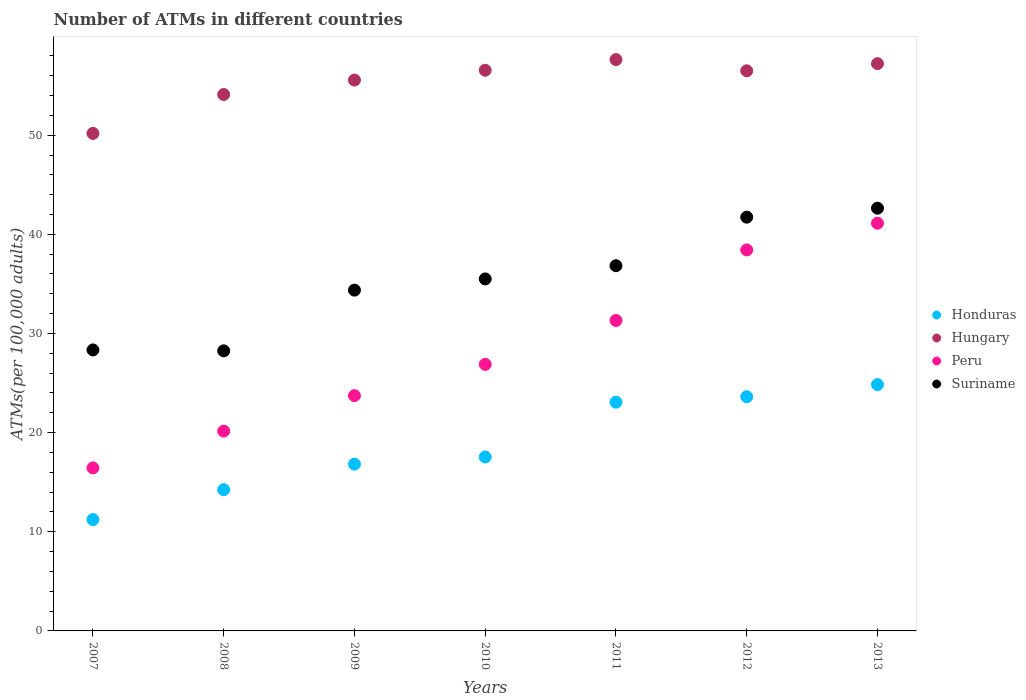What is the number of ATMs in Honduras in 2009?
Your response must be concise. 16.82. Across all years, what is the maximum number of ATMs in Suriname?
Keep it short and to the point. 42.64. Across all years, what is the minimum number of ATMs in Peru?
Give a very brief answer. 16.45. In which year was the number of ATMs in Hungary maximum?
Make the answer very short. 2011. In which year was the number of ATMs in Honduras minimum?
Offer a very short reply. 2007. What is the total number of ATMs in Honduras in the graph?
Offer a terse response. 131.38. What is the difference between the number of ATMs in Suriname in 2010 and that in 2013?
Give a very brief answer. -7.13. What is the difference between the number of ATMs in Honduras in 2013 and the number of ATMs in Suriname in 2008?
Offer a very short reply. -3.4. What is the average number of ATMs in Suriname per year?
Your answer should be very brief. 35.38. In the year 2012, what is the difference between the number of ATMs in Peru and number of ATMs in Honduras?
Ensure brevity in your answer.  14.81. In how many years, is the number of ATMs in Peru greater than 52?
Provide a succinct answer. 0. What is the ratio of the number of ATMs in Honduras in 2011 to that in 2013?
Your answer should be very brief. 0.93. Is the number of ATMs in Honduras in 2010 less than that in 2013?
Offer a very short reply. Yes. Is the difference between the number of ATMs in Peru in 2011 and 2012 greater than the difference between the number of ATMs in Honduras in 2011 and 2012?
Your answer should be compact. No. What is the difference between the highest and the second highest number of ATMs in Suriname?
Offer a terse response. 0.9. What is the difference between the highest and the lowest number of ATMs in Hungary?
Make the answer very short. 7.45. Is the sum of the number of ATMs in Hungary in 2008 and 2010 greater than the maximum number of ATMs in Peru across all years?
Offer a terse response. Yes. Is it the case that in every year, the sum of the number of ATMs in Hungary and number of ATMs in Peru  is greater than the number of ATMs in Honduras?
Your answer should be compact. Yes. Does the number of ATMs in Suriname monotonically increase over the years?
Your response must be concise. No. Is the number of ATMs in Hungary strictly less than the number of ATMs in Honduras over the years?
Provide a short and direct response. No. What is the difference between two consecutive major ticks on the Y-axis?
Offer a terse response. 10. Does the graph contain grids?
Provide a short and direct response. No. How many legend labels are there?
Ensure brevity in your answer.  4. What is the title of the graph?
Provide a short and direct response. Number of ATMs in different countries. What is the label or title of the Y-axis?
Provide a short and direct response. ATMs(per 100,0 adults). What is the ATMs(per 100,000 adults) in Honduras in 2007?
Provide a short and direct response. 11.23. What is the ATMs(per 100,000 adults) in Hungary in 2007?
Give a very brief answer. 50.18. What is the ATMs(per 100,000 adults) in Peru in 2007?
Give a very brief answer. 16.45. What is the ATMs(per 100,000 adults) in Suriname in 2007?
Your answer should be very brief. 28.34. What is the ATMs(per 100,000 adults) in Honduras in 2008?
Keep it short and to the point. 14.25. What is the ATMs(per 100,000 adults) in Hungary in 2008?
Keep it short and to the point. 54.1. What is the ATMs(per 100,000 adults) in Peru in 2008?
Offer a very short reply. 20.15. What is the ATMs(per 100,000 adults) in Suriname in 2008?
Ensure brevity in your answer.  28.25. What is the ATMs(per 100,000 adults) of Honduras in 2009?
Keep it short and to the point. 16.82. What is the ATMs(per 100,000 adults) of Hungary in 2009?
Keep it short and to the point. 55.56. What is the ATMs(per 100,000 adults) in Peru in 2009?
Your answer should be compact. 23.73. What is the ATMs(per 100,000 adults) of Suriname in 2009?
Your response must be concise. 34.37. What is the ATMs(per 100,000 adults) of Honduras in 2010?
Your answer should be very brief. 17.54. What is the ATMs(per 100,000 adults) of Hungary in 2010?
Ensure brevity in your answer.  56.55. What is the ATMs(per 100,000 adults) in Peru in 2010?
Offer a very short reply. 26.88. What is the ATMs(per 100,000 adults) in Suriname in 2010?
Provide a short and direct response. 35.5. What is the ATMs(per 100,000 adults) in Honduras in 2011?
Your response must be concise. 23.07. What is the ATMs(per 100,000 adults) of Hungary in 2011?
Provide a short and direct response. 57.63. What is the ATMs(per 100,000 adults) in Peru in 2011?
Your answer should be compact. 31.31. What is the ATMs(per 100,000 adults) in Suriname in 2011?
Your answer should be very brief. 36.83. What is the ATMs(per 100,000 adults) of Honduras in 2012?
Offer a very short reply. 23.62. What is the ATMs(per 100,000 adults) in Hungary in 2012?
Your answer should be very brief. 56.49. What is the ATMs(per 100,000 adults) in Peru in 2012?
Make the answer very short. 38.43. What is the ATMs(per 100,000 adults) of Suriname in 2012?
Give a very brief answer. 41.73. What is the ATMs(per 100,000 adults) in Honduras in 2013?
Offer a very short reply. 24.85. What is the ATMs(per 100,000 adults) in Hungary in 2013?
Your response must be concise. 57.22. What is the ATMs(per 100,000 adults) in Peru in 2013?
Offer a terse response. 41.12. What is the ATMs(per 100,000 adults) of Suriname in 2013?
Your answer should be very brief. 42.64. Across all years, what is the maximum ATMs(per 100,000 adults) in Honduras?
Offer a terse response. 24.85. Across all years, what is the maximum ATMs(per 100,000 adults) in Hungary?
Your answer should be compact. 57.63. Across all years, what is the maximum ATMs(per 100,000 adults) in Peru?
Give a very brief answer. 41.12. Across all years, what is the maximum ATMs(per 100,000 adults) of Suriname?
Your response must be concise. 42.64. Across all years, what is the minimum ATMs(per 100,000 adults) in Honduras?
Provide a succinct answer. 11.23. Across all years, what is the minimum ATMs(per 100,000 adults) in Hungary?
Your response must be concise. 50.18. Across all years, what is the minimum ATMs(per 100,000 adults) in Peru?
Your answer should be compact. 16.45. Across all years, what is the minimum ATMs(per 100,000 adults) in Suriname?
Give a very brief answer. 28.25. What is the total ATMs(per 100,000 adults) of Honduras in the graph?
Your answer should be compact. 131.38. What is the total ATMs(per 100,000 adults) in Hungary in the graph?
Provide a succinct answer. 387.73. What is the total ATMs(per 100,000 adults) in Peru in the graph?
Your answer should be very brief. 198.08. What is the total ATMs(per 100,000 adults) of Suriname in the graph?
Make the answer very short. 247.67. What is the difference between the ATMs(per 100,000 adults) in Honduras in 2007 and that in 2008?
Offer a very short reply. -3.02. What is the difference between the ATMs(per 100,000 adults) in Hungary in 2007 and that in 2008?
Offer a very short reply. -3.92. What is the difference between the ATMs(per 100,000 adults) in Peru in 2007 and that in 2008?
Ensure brevity in your answer.  -3.71. What is the difference between the ATMs(per 100,000 adults) of Suriname in 2007 and that in 2008?
Offer a terse response. 0.09. What is the difference between the ATMs(per 100,000 adults) of Honduras in 2007 and that in 2009?
Your response must be concise. -5.59. What is the difference between the ATMs(per 100,000 adults) of Hungary in 2007 and that in 2009?
Provide a short and direct response. -5.38. What is the difference between the ATMs(per 100,000 adults) of Peru in 2007 and that in 2009?
Give a very brief answer. -7.29. What is the difference between the ATMs(per 100,000 adults) in Suriname in 2007 and that in 2009?
Offer a very short reply. -6.03. What is the difference between the ATMs(per 100,000 adults) of Honduras in 2007 and that in 2010?
Give a very brief answer. -6.31. What is the difference between the ATMs(per 100,000 adults) of Hungary in 2007 and that in 2010?
Keep it short and to the point. -6.37. What is the difference between the ATMs(per 100,000 adults) of Peru in 2007 and that in 2010?
Make the answer very short. -10.44. What is the difference between the ATMs(per 100,000 adults) in Suriname in 2007 and that in 2010?
Your response must be concise. -7.16. What is the difference between the ATMs(per 100,000 adults) in Honduras in 2007 and that in 2011?
Offer a terse response. -11.84. What is the difference between the ATMs(per 100,000 adults) of Hungary in 2007 and that in 2011?
Offer a very short reply. -7.45. What is the difference between the ATMs(per 100,000 adults) in Peru in 2007 and that in 2011?
Offer a very short reply. -14.87. What is the difference between the ATMs(per 100,000 adults) of Suriname in 2007 and that in 2011?
Give a very brief answer. -8.49. What is the difference between the ATMs(per 100,000 adults) of Honduras in 2007 and that in 2012?
Give a very brief answer. -12.39. What is the difference between the ATMs(per 100,000 adults) of Hungary in 2007 and that in 2012?
Offer a terse response. -6.31. What is the difference between the ATMs(per 100,000 adults) in Peru in 2007 and that in 2012?
Give a very brief answer. -21.99. What is the difference between the ATMs(per 100,000 adults) of Suriname in 2007 and that in 2012?
Your answer should be very brief. -13.39. What is the difference between the ATMs(per 100,000 adults) in Honduras in 2007 and that in 2013?
Provide a succinct answer. -13.61. What is the difference between the ATMs(per 100,000 adults) of Hungary in 2007 and that in 2013?
Make the answer very short. -7.04. What is the difference between the ATMs(per 100,000 adults) in Peru in 2007 and that in 2013?
Offer a very short reply. -24.68. What is the difference between the ATMs(per 100,000 adults) of Suriname in 2007 and that in 2013?
Keep it short and to the point. -14.29. What is the difference between the ATMs(per 100,000 adults) in Honduras in 2008 and that in 2009?
Ensure brevity in your answer.  -2.58. What is the difference between the ATMs(per 100,000 adults) of Hungary in 2008 and that in 2009?
Make the answer very short. -1.46. What is the difference between the ATMs(per 100,000 adults) of Peru in 2008 and that in 2009?
Keep it short and to the point. -3.58. What is the difference between the ATMs(per 100,000 adults) in Suriname in 2008 and that in 2009?
Your answer should be compact. -6.12. What is the difference between the ATMs(per 100,000 adults) in Honduras in 2008 and that in 2010?
Ensure brevity in your answer.  -3.29. What is the difference between the ATMs(per 100,000 adults) of Hungary in 2008 and that in 2010?
Provide a succinct answer. -2.45. What is the difference between the ATMs(per 100,000 adults) in Peru in 2008 and that in 2010?
Your response must be concise. -6.73. What is the difference between the ATMs(per 100,000 adults) in Suriname in 2008 and that in 2010?
Make the answer very short. -7.25. What is the difference between the ATMs(per 100,000 adults) in Honduras in 2008 and that in 2011?
Make the answer very short. -8.83. What is the difference between the ATMs(per 100,000 adults) of Hungary in 2008 and that in 2011?
Provide a succinct answer. -3.52. What is the difference between the ATMs(per 100,000 adults) of Peru in 2008 and that in 2011?
Offer a terse response. -11.16. What is the difference between the ATMs(per 100,000 adults) in Suriname in 2008 and that in 2011?
Provide a short and direct response. -8.59. What is the difference between the ATMs(per 100,000 adults) in Honduras in 2008 and that in 2012?
Your response must be concise. -9.37. What is the difference between the ATMs(per 100,000 adults) of Hungary in 2008 and that in 2012?
Keep it short and to the point. -2.39. What is the difference between the ATMs(per 100,000 adults) of Peru in 2008 and that in 2012?
Your answer should be compact. -18.28. What is the difference between the ATMs(per 100,000 adults) in Suriname in 2008 and that in 2012?
Keep it short and to the point. -13.48. What is the difference between the ATMs(per 100,000 adults) in Honduras in 2008 and that in 2013?
Provide a short and direct response. -10.6. What is the difference between the ATMs(per 100,000 adults) of Hungary in 2008 and that in 2013?
Offer a very short reply. -3.11. What is the difference between the ATMs(per 100,000 adults) in Peru in 2008 and that in 2013?
Give a very brief answer. -20.97. What is the difference between the ATMs(per 100,000 adults) of Suriname in 2008 and that in 2013?
Ensure brevity in your answer.  -14.39. What is the difference between the ATMs(per 100,000 adults) of Honduras in 2009 and that in 2010?
Your response must be concise. -0.72. What is the difference between the ATMs(per 100,000 adults) of Hungary in 2009 and that in 2010?
Keep it short and to the point. -0.99. What is the difference between the ATMs(per 100,000 adults) of Peru in 2009 and that in 2010?
Keep it short and to the point. -3.15. What is the difference between the ATMs(per 100,000 adults) in Suriname in 2009 and that in 2010?
Offer a very short reply. -1.13. What is the difference between the ATMs(per 100,000 adults) of Honduras in 2009 and that in 2011?
Your response must be concise. -6.25. What is the difference between the ATMs(per 100,000 adults) in Hungary in 2009 and that in 2011?
Offer a terse response. -2.07. What is the difference between the ATMs(per 100,000 adults) of Peru in 2009 and that in 2011?
Keep it short and to the point. -7.58. What is the difference between the ATMs(per 100,000 adults) in Suriname in 2009 and that in 2011?
Make the answer very short. -2.46. What is the difference between the ATMs(per 100,000 adults) in Honduras in 2009 and that in 2012?
Offer a very short reply. -6.8. What is the difference between the ATMs(per 100,000 adults) of Hungary in 2009 and that in 2012?
Give a very brief answer. -0.93. What is the difference between the ATMs(per 100,000 adults) of Peru in 2009 and that in 2012?
Your answer should be very brief. -14.7. What is the difference between the ATMs(per 100,000 adults) of Suriname in 2009 and that in 2012?
Give a very brief answer. -7.36. What is the difference between the ATMs(per 100,000 adults) in Honduras in 2009 and that in 2013?
Keep it short and to the point. -8.02. What is the difference between the ATMs(per 100,000 adults) in Hungary in 2009 and that in 2013?
Give a very brief answer. -1.66. What is the difference between the ATMs(per 100,000 adults) of Peru in 2009 and that in 2013?
Offer a very short reply. -17.39. What is the difference between the ATMs(per 100,000 adults) of Suriname in 2009 and that in 2013?
Your response must be concise. -8.26. What is the difference between the ATMs(per 100,000 adults) in Honduras in 2010 and that in 2011?
Provide a succinct answer. -5.53. What is the difference between the ATMs(per 100,000 adults) of Hungary in 2010 and that in 2011?
Your answer should be very brief. -1.08. What is the difference between the ATMs(per 100,000 adults) of Peru in 2010 and that in 2011?
Keep it short and to the point. -4.43. What is the difference between the ATMs(per 100,000 adults) in Suriname in 2010 and that in 2011?
Offer a very short reply. -1.33. What is the difference between the ATMs(per 100,000 adults) of Honduras in 2010 and that in 2012?
Give a very brief answer. -6.08. What is the difference between the ATMs(per 100,000 adults) in Hungary in 2010 and that in 2012?
Make the answer very short. 0.06. What is the difference between the ATMs(per 100,000 adults) of Peru in 2010 and that in 2012?
Make the answer very short. -11.55. What is the difference between the ATMs(per 100,000 adults) in Suriname in 2010 and that in 2012?
Make the answer very short. -6.23. What is the difference between the ATMs(per 100,000 adults) of Honduras in 2010 and that in 2013?
Offer a very short reply. -7.3. What is the difference between the ATMs(per 100,000 adults) of Hungary in 2010 and that in 2013?
Keep it short and to the point. -0.67. What is the difference between the ATMs(per 100,000 adults) of Peru in 2010 and that in 2013?
Your response must be concise. -14.24. What is the difference between the ATMs(per 100,000 adults) of Suriname in 2010 and that in 2013?
Your response must be concise. -7.13. What is the difference between the ATMs(per 100,000 adults) in Honduras in 2011 and that in 2012?
Make the answer very short. -0.55. What is the difference between the ATMs(per 100,000 adults) of Hungary in 2011 and that in 2012?
Offer a terse response. 1.13. What is the difference between the ATMs(per 100,000 adults) in Peru in 2011 and that in 2012?
Make the answer very short. -7.12. What is the difference between the ATMs(per 100,000 adults) in Suriname in 2011 and that in 2012?
Keep it short and to the point. -4.9. What is the difference between the ATMs(per 100,000 adults) of Honduras in 2011 and that in 2013?
Make the answer very short. -1.77. What is the difference between the ATMs(per 100,000 adults) in Hungary in 2011 and that in 2013?
Your response must be concise. 0.41. What is the difference between the ATMs(per 100,000 adults) in Peru in 2011 and that in 2013?
Keep it short and to the point. -9.81. What is the difference between the ATMs(per 100,000 adults) of Suriname in 2011 and that in 2013?
Provide a succinct answer. -5.8. What is the difference between the ATMs(per 100,000 adults) of Honduras in 2012 and that in 2013?
Give a very brief answer. -1.22. What is the difference between the ATMs(per 100,000 adults) in Hungary in 2012 and that in 2013?
Make the answer very short. -0.72. What is the difference between the ATMs(per 100,000 adults) in Peru in 2012 and that in 2013?
Offer a very short reply. -2.69. What is the difference between the ATMs(per 100,000 adults) of Suriname in 2012 and that in 2013?
Provide a succinct answer. -0.9. What is the difference between the ATMs(per 100,000 adults) of Honduras in 2007 and the ATMs(per 100,000 adults) of Hungary in 2008?
Offer a very short reply. -42.87. What is the difference between the ATMs(per 100,000 adults) of Honduras in 2007 and the ATMs(per 100,000 adults) of Peru in 2008?
Keep it short and to the point. -8.92. What is the difference between the ATMs(per 100,000 adults) of Honduras in 2007 and the ATMs(per 100,000 adults) of Suriname in 2008?
Provide a short and direct response. -17.02. What is the difference between the ATMs(per 100,000 adults) in Hungary in 2007 and the ATMs(per 100,000 adults) in Peru in 2008?
Keep it short and to the point. 30.03. What is the difference between the ATMs(per 100,000 adults) of Hungary in 2007 and the ATMs(per 100,000 adults) of Suriname in 2008?
Offer a terse response. 21.93. What is the difference between the ATMs(per 100,000 adults) in Peru in 2007 and the ATMs(per 100,000 adults) in Suriname in 2008?
Your answer should be compact. -11.8. What is the difference between the ATMs(per 100,000 adults) in Honduras in 2007 and the ATMs(per 100,000 adults) in Hungary in 2009?
Offer a very short reply. -44.33. What is the difference between the ATMs(per 100,000 adults) in Honduras in 2007 and the ATMs(per 100,000 adults) in Peru in 2009?
Your response must be concise. -12.5. What is the difference between the ATMs(per 100,000 adults) in Honduras in 2007 and the ATMs(per 100,000 adults) in Suriname in 2009?
Give a very brief answer. -23.14. What is the difference between the ATMs(per 100,000 adults) in Hungary in 2007 and the ATMs(per 100,000 adults) in Peru in 2009?
Your response must be concise. 26.45. What is the difference between the ATMs(per 100,000 adults) in Hungary in 2007 and the ATMs(per 100,000 adults) in Suriname in 2009?
Provide a succinct answer. 15.81. What is the difference between the ATMs(per 100,000 adults) of Peru in 2007 and the ATMs(per 100,000 adults) of Suriname in 2009?
Your answer should be very brief. -17.93. What is the difference between the ATMs(per 100,000 adults) in Honduras in 2007 and the ATMs(per 100,000 adults) in Hungary in 2010?
Ensure brevity in your answer.  -45.32. What is the difference between the ATMs(per 100,000 adults) in Honduras in 2007 and the ATMs(per 100,000 adults) in Peru in 2010?
Make the answer very short. -15.65. What is the difference between the ATMs(per 100,000 adults) of Honduras in 2007 and the ATMs(per 100,000 adults) of Suriname in 2010?
Provide a succinct answer. -24.27. What is the difference between the ATMs(per 100,000 adults) in Hungary in 2007 and the ATMs(per 100,000 adults) in Peru in 2010?
Provide a short and direct response. 23.3. What is the difference between the ATMs(per 100,000 adults) in Hungary in 2007 and the ATMs(per 100,000 adults) in Suriname in 2010?
Your answer should be compact. 14.68. What is the difference between the ATMs(per 100,000 adults) in Peru in 2007 and the ATMs(per 100,000 adults) in Suriname in 2010?
Keep it short and to the point. -19.06. What is the difference between the ATMs(per 100,000 adults) in Honduras in 2007 and the ATMs(per 100,000 adults) in Hungary in 2011?
Make the answer very short. -46.4. What is the difference between the ATMs(per 100,000 adults) of Honduras in 2007 and the ATMs(per 100,000 adults) of Peru in 2011?
Make the answer very short. -20.08. What is the difference between the ATMs(per 100,000 adults) of Honduras in 2007 and the ATMs(per 100,000 adults) of Suriname in 2011?
Your answer should be compact. -25.6. What is the difference between the ATMs(per 100,000 adults) in Hungary in 2007 and the ATMs(per 100,000 adults) in Peru in 2011?
Give a very brief answer. 18.87. What is the difference between the ATMs(per 100,000 adults) of Hungary in 2007 and the ATMs(per 100,000 adults) of Suriname in 2011?
Ensure brevity in your answer.  13.35. What is the difference between the ATMs(per 100,000 adults) in Peru in 2007 and the ATMs(per 100,000 adults) in Suriname in 2011?
Provide a short and direct response. -20.39. What is the difference between the ATMs(per 100,000 adults) of Honduras in 2007 and the ATMs(per 100,000 adults) of Hungary in 2012?
Provide a succinct answer. -45.26. What is the difference between the ATMs(per 100,000 adults) of Honduras in 2007 and the ATMs(per 100,000 adults) of Peru in 2012?
Your answer should be compact. -27.2. What is the difference between the ATMs(per 100,000 adults) of Honduras in 2007 and the ATMs(per 100,000 adults) of Suriname in 2012?
Provide a short and direct response. -30.5. What is the difference between the ATMs(per 100,000 adults) in Hungary in 2007 and the ATMs(per 100,000 adults) in Peru in 2012?
Ensure brevity in your answer.  11.75. What is the difference between the ATMs(per 100,000 adults) of Hungary in 2007 and the ATMs(per 100,000 adults) of Suriname in 2012?
Keep it short and to the point. 8.45. What is the difference between the ATMs(per 100,000 adults) of Peru in 2007 and the ATMs(per 100,000 adults) of Suriname in 2012?
Your answer should be very brief. -25.29. What is the difference between the ATMs(per 100,000 adults) of Honduras in 2007 and the ATMs(per 100,000 adults) of Hungary in 2013?
Your answer should be very brief. -45.99. What is the difference between the ATMs(per 100,000 adults) in Honduras in 2007 and the ATMs(per 100,000 adults) in Peru in 2013?
Provide a short and direct response. -29.89. What is the difference between the ATMs(per 100,000 adults) of Honduras in 2007 and the ATMs(per 100,000 adults) of Suriname in 2013?
Offer a very short reply. -31.41. What is the difference between the ATMs(per 100,000 adults) in Hungary in 2007 and the ATMs(per 100,000 adults) in Peru in 2013?
Keep it short and to the point. 9.06. What is the difference between the ATMs(per 100,000 adults) in Hungary in 2007 and the ATMs(per 100,000 adults) in Suriname in 2013?
Make the answer very short. 7.54. What is the difference between the ATMs(per 100,000 adults) in Peru in 2007 and the ATMs(per 100,000 adults) in Suriname in 2013?
Your answer should be compact. -26.19. What is the difference between the ATMs(per 100,000 adults) of Honduras in 2008 and the ATMs(per 100,000 adults) of Hungary in 2009?
Your answer should be very brief. -41.31. What is the difference between the ATMs(per 100,000 adults) in Honduras in 2008 and the ATMs(per 100,000 adults) in Peru in 2009?
Your response must be concise. -9.48. What is the difference between the ATMs(per 100,000 adults) of Honduras in 2008 and the ATMs(per 100,000 adults) of Suriname in 2009?
Provide a succinct answer. -20.12. What is the difference between the ATMs(per 100,000 adults) in Hungary in 2008 and the ATMs(per 100,000 adults) in Peru in 2009?
Make the answer very short. 30.37. What is the difference between the ATMs(per 100,000 adults) of Hungary in 2008 and the ATMs(per 100,000 adults) of Suriname in 2009?
Offer a terse response. 19.73. What is the difference between the ATMs(per 100,000 adults) in Peru in 2008 and the ATMs(per 100,000 adults) in Suriname in 2009?
Provide a succinct answer. -14.22. What is the difference between the ATMs(per 100,000 adults) of Honduras in 2008 and the ATMs(per 100,000 adults) of Hungary in 2010?
Ensure brevity in your answer.  -42.3. What is the difference between the ATMs(per 100,000 adults) in Honduras in 2008 and the ATMs(per 100,000 adults) in Peru in 2010?
Ensure brevity in your answer.  -12.63. What is the difference between the ATMs(per 100,000 adults) of Honduras in 2008 and the ATMs(per 100,000 adults) of Suriname in 2010?
Make the answer very short. -21.25. What is the difference between the ATMs(per 100,000 adults) in Hungary in 2008 and the ATMs(per 100,000 adults) in Peru in 2010?
Provide a short and direct response. 27.22. What is the difference between the ATMs(per 100,000 adults) in Hungary in 2008 and the ATMs(per 100,000 adults) in Suriname in 2010?
Your answer should be very brief. 18.6. What is the difference between the ATMs(per 100,000 adults) of Peru in 2008 and the ATMs(per 100,000 adults) of Suriname in 2010?
Your answer should be compact. -15.35. What is the difference between the ATMs(per 100,000 adults) of Honduras in 2008 and the ATMs(per 100,000 adults) of Hungary in 2011?
Keep it short and to the point. -43.38. What is the difference between the ATMs(per 100,000 adults) in Honduras in 2008 and the ATMs(per 100,000 adults) in Peru in 2011?
Offer a very short reply. -17.07. What is the difference between the ATMs(per 100,000 adults) in Honduras in 2008 and the ATMs(per 100,000 adults) in Suriname in 2011?
Offer a very short reply. -22.59. What is the difference between the ATMs(per 100,000 adults) in Hungary in 2008 and the ATMs(per 100,000 adults) in Peru in 2011?
Keep it short and to the point. 22.79. What is the difference between the ATMs(per 100,000 adults) of Hungary in 2008 and the ATMs(per 100,000 adults) of Suriname in 2011?
Make the answer very short. 17.27. What is the difference between the ATMs(per 100,000 adults) in Peru in 2008 and the ATMs(per 100,000 adults) in Suriname in 2011?
Make the answer very short. -16.68. What is the difference between the ATMs(per 100,000 adults) of Honduras in 2008 and the ATMs(per 100,000 adults) of Hungary in 2012?
Provide a succinct answer. -42.25. What is the difference between the ATMs(per 100,000 adults) of Honduras in 2008 and the ATMs(per 100,000 adults) of Peru in 2012?
Give a very brief answer. -24.18. What is the difference between the ATMs(per 100,000 adults) in Honduras in 2008 and the ATMs(per 100,000 adults) in Suriname in 2012?
Provide a succinct answer. -27.49. What is the difference between the ATMs(per 100,000 adults) of Hungary in 2008 and the ATMs(per 100,000 adults) of Peru in 2012?
Make the answer very short. 15.67. What is the difference between the ATMs(per 100,000 adults) in Hungary in 2008 and the ATMs(per 100,000 adults) in Suriname in 2012?
Your answer should be very brief. 12.37. What is the difference between the ATMs(per 100,000 adults) of Peru in 2008 and the ATMs(per 100,000 adults) of Suriname in 2012?
Keep it short and to the point. -21.58. What is the difference between the ATMs(per 100,000 adults) of Honduras in 2008 and the ATMs(per 100,000 adults) of Hungary in 2013?
Your answer should be compact. -42.97. What is the difference between the ATMs(per 100,000 adults) in Honduras in 2008 and the ATMs(per 100,000 adults) in Peru in 2013?
Ensure brevity in your answer.  -26.88. What is the difference between the ATMs(per 100,000 adults) of Honduras in 2008 and the ATMs(per 100,000 adults) of Suriname in 2013?
Offer a terse response. -28.39. What is the difference between the ATMs(per 100,000 adults) of Hungary in 2008 and the ATMs(per 100,000 adults) of Peru in 2013?
Your answer should be compact. 12.98. What is the difference between the ATMs(per 100,000 adults) in Hungary in 2008 and the ATMs(per 100,000 adults) in Suriname in 2013?
Offer a terse response. 11.47. What is the difference between the ATMs(per 100,000 adults) of Peru in 2008 and the ATMs(per 100,000 adults) of Suriname in 2013?
Your answer should be compact. -22.48. What is the difference between the ATMs(per 100,000 adults) in Honduras in 2009 and the ATMs(per 100,000 adults) in Hungary in 2010?
Provide a succinct answer. -39.73. What is the difference between the ATMs(per 100,000 adults) in Honduras in 2009 and the ATMs(per 100,000 adults) in Peru in 2010?
Your answer should be very brief. -10.06. What is the difference between the ATMs(per 100,000 adults) in Honduras in 2009 and the ATMs(per 100,000 adults) in Suriname in 2010?
Provide a succinct answer. -18.68. What is the difference between the ATMs(per 100,000 adults) in Hungary in 2009 and the ATMs(per 100,000 adults) in Peru in 2010?
Offer a terse response. 28.68. What is the difference between the ATMs(per 100,000 adults) in Hungary in 2009 and the ATMs(per 100,000 adults) in Suriname in 2010?
Ensure brevity in your answer.  20.06. What is the difference between the ATMs(per 100,000 adults) of Peru in 2009 and the ATMs(per 100,000 adults) of Suriname in 2010?
Your response must be concise. -11.77. What is the difference between the ATMs(per 100,000 adults) in Honduras in 2009 and the ATMs(per 100,000 adults) in Hungary in 2011?
Provide a succinct answer. -40.8. What is the difference between the ATMs(per 100,000 adults) of Honduras in 2009 and the ATMs(per 100,000 adults) of Peru in 2011?
Your response must be concise. -14.49. What is the difference between the ATMs(per 100,000 adults) in Honduras in 2009 and the ATMs(per 100,000 adults) in Suriname in 2011?
Provide a succinct answer. -20.01. What is the difference between the ATMs(per 100,000 adults) of Hungary in 2009 and the ATMs(per 100,000 adults) of Peru in 2011?
Your answer should be very brief. 24.25. What is the difference between the ATMs(per 100,000 adults) of Hungary in 2009 and the ATMs(per 100,000 adults) of Suriname in 2011?
Your answer should be very brief. 18.73. What is the difference between the ATMs(per 100,000 adults) of Peru in 2009 and the ATMs(per 100,000 adults) of Suriname in 2011?
Offer a terse response. -13.1. What is the difference between the ATMs(per 100,000 adults) of Honduras in 2009 and the ATMs(per 100,000 adults) of Hungary in 2012?
Offer a terse response. -39.67. What is the difference between the ATMs(per 100,000 adults) in Honduras in 2009 and the ATMs(per 100,000 adults) in Peru in 2012?
Your response must be concise. -21.61. What is the difference between the ATMs(per 100,000 adults) of Honduras in 2009 and the ATMs(per 100,000 adults) of Suriname in 2012?
Ensure brevity in your answer.  -24.91. What is the difference between the ATMs(per 100,000 adults) in Hungary in 2009 and the ATMs(per 100,000 adults) in Peru in 2012?
Your answer should be very brief. 17.13. What is the difference between the ATMs(per 100,000 adults) of Hungary in 2009 and the ATMs(per 100,000 adults) of Suriname in 2012?
Ensure brevity in your answer.  13.83. What is the difference between the ATMs(per 100,000 adults) in Peru in 2009 and the ATMs(per 100,000 adults) in Suriname in 2012?
Your answer should be very brief. -18. What is the difference between the ATMs(per 100,000 adults) of Honduras in 2009 and the ATMs(per 100,000 adults) of Hungary in 2013?
Give a very brief answer. -40.39. What is the difference between the ATMs(per 100,000 adults) in Honduras in 2009 and the ATMs(per 100,000 adults) in Peru in 2013?
Offer a terse response. -24.3. What is the difference between the ATMs(per 100,000 adults) in Honduras in 2009 and the ATMs(per 100,000 adults) in Suriname in 2013?
Keep it short and to the point. -25.81. What is the difference between the ATMs(per 100,000 adults) of Hungary in 2009 and the ATMs(per 100,000 adults) of Peru in 2013?
Offer a terse response. 14.44. What is the difference between the ATMs(per 100,000 adults) of Hungary in 2009 and the ATMs(per 100,000 adults) of Suriname in 2013?
Your answer should be very brief. 12.92. What is the difference between the ATMs(per 100,000 adults) of Peru in 2009 and the ATMs(per 100,000 adults) of Suriname in 2013?
Make the answer very short. -18.91. What is the difference between the ATMs(per 100,000 adults) of Honduras in 2010 and the ATMs(per 100,000 adults) of Hungary in 2011?
Your response must be concise. -40.09. What is the difference between the ATMs(per 100,000 adults) of Honduras in 2010 and the ATMs(per 100,000 adults) of Peru in 2011?
Offer a terse response. -13.77. What is the difference between the ATMs(per 100,000 adults) in Honduras in 2010 and the ATMs(per 100,000 adults) in Suriname in 2011?
Offer a terse response. -19.29. What is the difference between the ATMs(per 100,000 adults) in Hungary in 2010 and the ATMs(per 100,000 adults) in Peru in 2011?
Make the answer very short. 25.24. What is the difference between the ATMs(per 100,000 adults) in Hungary in 2010 and the ATMs(per 100,000 adults) in Suriname in 2011?
Your response must be concise. 19.72. What is the difference between the ATMs(per 100,000 adults) in Peru in 2010 and the ATMs(per 100,000 adults) in Suriname in 2011?
Offer a very short reply. -9.95. What is the difference between the ATMs(per 100,000 adults) of Honduras in 2010 and the ATMs(per 100,000 adults) of Hungary in 2012?
Provide a short and direct response. -38.95. What is the difference between the ATMs(per 100,000 adults) of Honduras in 2010 and the ATMs(per 100,000 adults) of Peru in 2012?
Your answer should be very brief. -20.89. What is the difference between the ATMs(per 100,000 adults) in Honduras in 2010 and the ATMs(per 100,000 adults) in Suriname in 2012?
Offer a very short reply. -24.19. What is the difference between the ATMs(per 100,000 adults) of Hungary in 2010 and the ATMs(per 100,000 adults) of Peru in 2012?
Give a very brief answer. 18.12. What is the difference between the ATMs(per 100,000 adults) of Hungary in 2010 and the ATMs(per 100,000 adults) of Suriname in 2012?
Provide a short and direct response. 14.82. What is the difference between the ATMs(per 100,000 adults) of Peru in 2010 and the ATMs(per 100,000 adults) of Suriname in 2012?
Offer a terse response. -14.85. What is the difference between the ATMs(per 100,000 adults) in Honduras in 2010 and the ATMs(per 100,000 adults) in Hungary in 2013?
Make the answer very short. -39.67. What is the difference between the ATMs(per 100,000 adults) in Honduras in 2010 and the ATMs(per 100,000 adults) in Peru in 2013?
Make the answer very short. -23.58. What is the difference between the ATMs(per 100,000 adults) of Honduras in 2010 and the ATMs(per 100,000 adults) of Suriname in 2013?
Make the answer very short. -25.09. What is the difference between the ATMs(per 100,000 adults) in Hungary in 2010 and the ATMs(per 100,000 adults) in Peru in 2013?
Offer a terse response. 15.43. What is the difference between the ATMs(per 100,000 adults) in Hungary in 2010 and the ATMs(per 100,000 adults) in Suriname in 2013?
Your response must be concise. 13.92. What is the difference between the ATMs(per 100,000 adults) in Peru in 2010 and the ATMs(per 100,000 adults) in Suriname in 2013?
Your response must be concise. -15.75. What is the difference between the ATMs(per 100,000 adults) in Honduras in 2011 and the ATMs(per 100,000 adults) in Hungary in 2012?
Your answer should be very brief. -33.42. What is the difference between the ATMs(per 100,000 adults) in Honduras in 2011 and the ATMs(per 100,000 adults) in Peru in 2012?
Offer a terse response. -15.36. What is the difference between the ATMs(per 100,000 adults) of Honduras in 2011 and the ATMs(per 100,000 adults) of Suriname in 2012?
Offer a very short reply. -18.66. What is the difference between the ATMs(per 100,000 adults) of Hungary in 2011 and the ATMs(per 100,000 adults) of Peru in 2012?
Give a very brief answer. 19.2. What is the difference between the ATMs(per 100,000 adults) in Hungary in 2011 and the ATMs(per 100,000 adults) in Suriname in 2012?
Give a very brief answer. 15.89. What is the difference between the ATMs(per 100,000 adults) in Peru in 2011 and the ATMs(per 100,000 adults) in Suriname in 2012?
Keep it short and to the point. -10.42. What is the difference between the ATMs(per 100,000 adults) in Honduras in 2011 and the ATMs(per 100,000 adults) in Hungary in 2013?
Your answer should be compact. -34.14. What is the difference between the ATMs(per 100,000 adults) of Honduras in 2011 and the ATMs(per 100,000 adults) of Peru in 2013?
Give a very brief answer. -18.05. What is the difference between the ATMs(per 100,000 adults) in Honduras in 2011 and the ATMs(per 100,000 adults) in Suriname in 2013?
Give a very brief answer. -19.56. What is the difference between the ATMs(per 100,000 adults) of Hungary in 2011 and the ATMs(per 100,000 adults) of Peru in 2013?
Ensure brevity in your answer.  16.5. What is the difference between the ATMs(per 100,000 adults) in Hungary in 2011 and the ATMs(per 100,000 adults) in Suriname in 2013?
Ensure brevity in your answer.  14.99. What is the difference between the ATMs(per 100,000 adults) of Peru in 2011 and the ATMs(per 100,000 adults) of Suriname in 2013?
Provide a succinct answer. -11.32. What is the difference between the ATMs(per 100,000 adults) of Honduras in 2012 and the ATMs(per 100,000 adults) of Hungary in 2013?
Ensure brevity in your answer.  -33.6. What is the difference between the ATMs(per 100,000 adults) in Honduras in 2012 and the ATMs(per 100,000 adults) in Peru in 2013?
Offer a terse response. -17.5. What is the difference between the ATMs(per 100,000 adults) in Honduras in 2012 and the ATMs(per 100,000 adults) in Suriname in 2013?
Ensure brevity in your answer.  -19.02. What is the difference between the ATMs(per 100,000 adults) in Hungary in 2012 and the ATMs(per 100,000 adults) in Peru in 2013?
Offer a terse response. 15.37. What is the difference between the ATMs(per 100,000 adults) in Hungary in 2012 and the ATMs(per 100,000 adults) in Suriname in 2013?
Ensure brevity in your answer.  13.86. What is the difference between the ATMs(per 100,000 adults) of Peru in 2012 and the ATMs(per 100,000 adults) of Suriname in 2013?
Your answer should be compact. -4.21. What is the average ATMs(per 100,000 adults) of Honduras per year?
Make the answer very short. 18.77. What is the average ATMs(per 100,000 adults) of Hungary per year?
Your answer should be compact. 55.39. What is the average ATMs(per 100,000 adults) of Peru per year?
Make the answer very short. 28.3. What is the average ATMs(per 100,000 adults) of Suriname per year?
Offer a terse response. 35.38. In the year 2007, what is the difference between the ATMs(per 100,000 adults) in Honduras and ATMs(per 100,000 adults) in Hungary?
Make the answer very short. -38.95. In the year 2007, what is the difference between the ATMs(per 100,000 adults) of Honduras and ATMs(per 100,000 adults) of Peru?
Offer a very short reply. -5.21. In the year 2007, what is the difference between the ATMs(per 100,000 adults) in Honduras and ATMs(per 100,000 adults) in Suriname?
Ensure brevity in your answer.  -17.11. In the year 2007, what is the difference between the ATMs(per 100,000 adults) in Hungary and ATMs(per 100,000 adults) in Peru?
Make the answer very short. 33.74. In the year 2007, what is the difference between the ATMs(per 100,000 adults) in Hungary and ATMs(per 100,000 adults) in Suriname?
Make the answer very short. 21.84. In the year 2007, what is the difference between the ATMs(per 100,000 adults) in Peru and ATMs(per 100,000 adults) in Suriname?
Offer a terse response. -11.9. In the year 2008, what is the difference between the ATMs(per 100,000 adults) of Honduras and ATMs(per 100,000 adults) of Hungary?
Ensure brevity in your answer.  -39.86. In the year 2008, what is the difference between the ATMs(per 100,000 adults) of Honduras and ATMs(per 100,000 adults) of Peru?
Keep it short and to the point. -5.91. In the year 2008, what is the difference between the ATMs(per 100,000 adults) in Honduras and ATMs(per 100,000 adults) in Suriname?
Give a very brief answer. -14. In the year 2008, what is the difference between the ATMs(per 100,000 adults) of Hungary and ATMs(per 100,000 adults) of Peru?
Offer a very short reply. 33.95. In the year 2008, what is the difference between the ATMs(per 100,000 adults) in Hungary and ATMs(per 100,000 adults) in Suriname?
Give a very brief answer. 25.85. In the year 2008, what is the difference between the ATMs(per 100,000 adults) in Peru and ATMs(per 100,000 adults) in Suriname?
Keep it short and to the point. -8.1. In the year 2009, what is the difference between the ATMs(per 100,000 adults) in Honduras and ATMs(per 100,000 adults) in Hungary?
Provide a short and direct response. -38.74. In the year 2009, what is the difference between the ATMs(per 100,000 adults) in Honduras and ATMs(per 100,000 adults) in Peru?
Provide a short and direct response. -6.91. In the year 2009, what is the difference between the ATMs(per 100,000 adults) of Honduras and ATMs(per 100,000 adults) of Suriname?
Keep it short and to the point. -17.55. In the year 2009, what is the difference between the ATMs(per 100,000 adults) of Hungary and ATMs(per 100,000 adults) of Peru?
Your response must be concise. 31.83. In the year 2009, what is the difference between the ATMs(per 100,000 adults) in Hungary and ATMs(per 100,000 adults) in Suriname?
Ensure brevity in your answer.  21.19. In the year 2009, what is the difference between the ATMs(per 100,000 adults) in Peru and ATMs(per 100,000 adults) in Suriname?
Keep it short and to the point. -10.64. In the year 2010, what is the difference between the ATMs(per 100,000 adults) of Honduras and ATMs(per 100,000 adults) of Hungary?
Make the answer very short. -39.01. In the year 2010, what is the difference between the ATMs(per 100,000 adults) of Honduras and ATMs(per 100,000 adults) of Peru?
Give a very brief answer. -9.34. In the year 2010, what is the difference between the ATMs(per 100,000 adults) of Honduras and ATMs(per 100,000 adults) of Suriname?
Offer a very short reply. -17.96. In the year 2010, what is the difference between the ATMs(per 100,000 adults) of Hungary and ATMs(per 100,000 adults) of Peru?
Make the answer very short. 29.67. In the year 2010, what is the difference between the ATMs(per 100,000 adults) of Hungary and ATMs(per 100,000 adults) of Suriname?
Provide a short and direct response. 21.05. In the year 2010, what is the difference between the ATMs(per 100,000 adults) of Peru and ATMs(per 100,000 adults) of Suriname?
Your response must be concise. -8.62. In the year 2011, what is the difference between the ATMs(per 100,000 adults) in Honduras and ATMs(per 100,000 adults) in Hungary?
Give a very brief answer. -34.55. In the year 2011, what is the difference between the ATMs(per 100,000 adults) of Honduras and ATMs(per 100,000 adults) of Peru?
Ensure brevity in your answer.  -8.24. In the year 2011, what is the difference between the ATMs(per 100,000 adults) in Honduras and ATMs(per 100,000 adults) in Suriname?
Offer a very short reply. -13.76. In the year 2011, what is the difference between the ATMs(per 100,000 adults) in Hungary and ATMs(per 100,000 adults) in Peru?
Your answer should be compact. 26.31. In the year 2011, what is the difference between the ATMs(per 100,000 adults) of Hungary and ATMs(per 100,000 adults) of Suriname?
Your response must be concise. 20.79. In the year 2011, what is the difference between the ATMs(per 100,000 adults) in Peru and ATMs(per 100,000 adults) in Suriname?
Keep it short and to the point. -5.52. In the year 2012, what is the difference between the ATMs(per 100,000 adults) in Honduras and ATMs(per 100,000 adults) in Hungary?
Provide a succinct answer. -32.87. In the year 2012, what is the difference between the ATMs(per 100,000 adults) in Honduras and ATMs(per 100,000 adults) in Peru?
Keep it short and to the point. -14.81. In the year 2012, what is the difference between the ATMs(per 100,000 adults) of Honduras and ATMs(per 100,000 adults) of Suriname?
Your answer should be compact. -18.11. In the year 2012, what is the difference between the ATMs(per 100,000 adults) of Hungary and ATMs(per 100,000 adults) of Peru?
Your answer should be very brief. 18.06. In the year 2012, what is the difference between the ATMs(per 100,000 adults) of Hungary and ATMs(per 100,000 adults) of Suriname?
Give a very brief answer. 14.76. In the year 2012, what is the difference between the ATMs(per 100,000 adults) of Peru and ATMs(per 100,000 adults) of Suriname?
Keep it short and to the point. -3.3. In the year 2013, what is the difference between the ATMs(per 100,000 adults) of Honduras and ATMs(per 100,000 adults) of Hungary?
Your response must be concise. -32.37. In the year 2013, what is the difference between the ATMs(per 100,000 adults) in Honduras and ATMs(per 100,000 adults) in Peru?
Provide a succinct answer. -16.28. In the year 2013, what is the difference between the ATMs(per 100,000 adults) of Honduras and ATMs(per 100,000 adults) of Suriname?
Provide a short and direct response. -17.79. In the year 2013, what is the difference between the ATMs(per 100,000 adults) of Hungary and ATMs(per 100,000 adults) of Peru?
Offer a terse response. 16.09. In the year 2013, what is the difference between the ATMs(per 100,000 adults) of Hungary and ATMs(per 100,000 adults) of Suriname?
Provide a succinct answer. 14.58. In the year 2013, what is the difference between the ATMs(per 100,000 adults) in Peru and ATMs(per 100,000 adults) in Suriname?
Provide a short and direct response. -1.51. What is the ratio of the ATMs(per 100,000 adults) of Honduras in 2007 to that in 2008?
Offer a very short reply. 0.79. What is the ratio of the ATMs(per 100,000 adults) in Hungary in 2007 to that in 2008?
Provide a short and direct response. 0.93. What is the ratio of the ATMs(per 100,000 adults) of Peru in 2007 to that in 2008?
Your answer should be very brief. 0.82. What is the ratio of the ATMs(per 100,000 adults) of Suriname in 2007 to that in 2008?
Provide a short and direct response. 1. What is the ratio of the ATMs(per 100,000 adults) of Honduras in 2007 to that in 2009?
Your answer should be very brief. 0.67. What is the ratio of the ATMs(per 100,000 adults) in Hungary in 2007 to that in 2009?
Your response must be concise. 0.9. What is the ratio of the ATMs(per 100,000 adults) of Peru in 2007 to that in 2009?
Your answer should be compact. 0.69. What is the ratio of the ATMs(per 100,000 adults) of Suriname in 2007 to that in 2009?
Your answer should be compact. 0.82. What is the ratio of the ATMs(per 100,000 adults) of Honduras in 2007 to that in 2010?
Offer a very short reply. 0.64. What is the ratio of the ATMs(per 100,000 adults) of Hungary in 2007 to that in 2010?
Give a very brief answer. 0.89. What is the ratio of the ATMs(per 100,000 adults) in Peru in 2007 to that in 2010?
Offer a terse response. 0.61. What is the ratio of the ATMs(per 100,000 adults) of Suriname in 2007 to that in 2010?
Provide a succinct answer. 0.8. What is the ratio of the ATMs(per 100,000 adults) of Honduras in 2007 to that in 2011?
Provide a short and direct response. 0.49. What is the ratio of the ATMs(per 100,000 adults) in Hungary in 2007 to that in 2011?
Provide a succinct answer. 0.87. What is the ratio of the ATMs(per 100,000 adults) in Peru in 2007 to that in 2011?
Make the answer very short. 0.53. What is the ratio of the ATMs(per 100,000 adults) of Suriname in 2007 to that in 2011?
Offer a terse response. 0.77. What is the ratio of the ATMs(per 100,000 adults) in Honduras in 2007 to that in 2012?
Make the answer very short. 0.48. What is the ratio of the ATMs(per 100,000 adults) in Hungary in 2007 to that in 2012?
Offer a very short reply. 0.89. What is the ratio of the ATMs(per 100,000 adults) of Peru in 2007 to that in 2012?
Provide a short and direct response. 0.43. What is the ratio of the ATMs(per 100,000 adults) of Suriname in 2007 to that in 2012?
Give a very brief answer. 0.68. What is the ratio of the ATMs(per 100,000 adults) in Honduras in 2007 to that in 2013?
Offer a very short reply. 0.45. What is the ratio of the ATMs(per 100,000 adults) in Hungary in 2007 to that in 2013?
Ensure brevity in your answer.  0.88. What is the ratio of the ATMs(per 100,000 adults) in Peru in 2007 to that in 2013?
Offer a very short reply. 0.4. What is the ratio of the ATMs(per 100,000 adults) in Suriname in 2007 to that in 2013?
Your response must be concise. 0.66. What is the ratio of the ATMs(per 100,000 adults) in Honduras in 2008 to that in 2009?
Keep it short and to the point. 0.85. What is the ratio of the ATMs(per 100,000 adults) of Hungary in 2008 to that in 2009?
Your response must be concise. 0.97. What is the ratio of the ATMs(per 100,000 adults) of Peru in 2008 to that in 2009?
Make the answer very short. 0.85. What is the ratio of the ATMs(per 100,000 adults) of Suriname in 2008 to that in 2009?
Your answer should be very brief. 0.82. What is the ratio of the ATMs(per 100,000 adults) in Honduras in 2008 to that in 2010?
Your answer should be very brief. 0.81. What is the ratio of the ATMs(per 100,000 adults) in Hungary in 2008 to that in 2010?
Give a very brief answer. 0.96. What is the ratio of the ATMs(per 100,000 adults) of Peru in 2008 to that in 2010?
Ensure brevity in your answer.  0.75. What is the ratio of the ATMs(per 100,000 adults) of Suriname in 2008 to that in 2010?
Provide a short and direct response. 0.8. What is the ratio of the ATMs(per 100,000 adults) of Honduras in 2008 to that in 2011?
Your answer should be compact. 0.62. What is the ratio of the ATMs(per 100,000 adults) of Hungary in 2008 to that in 2011?
Ensure brevity in your answer.  0.94. What is the ratio of the ATMs(per 100,000 adults) in Peru in 2008 to that in 2011?
Your answer should be compact. 0.64. What is the ratio of the ATMs(per 100,000 adults) in Suriname in 2008 to that in 2011?
Provide a short and direct response. 0.77. What is the ratio of the ATMs(per 100,000 adults) in Honduras in 2008 to that in 2012?
Offer a terse response. 0.6. What is the ratio of the ATMs(per 100,000 adults) of Hungary in 2008 to that in 2012?
Give a very brief answer. 0.96. What is the ratio of the ATMs(per 100,000 adults) in Peru in 2008 to that in 2012?
Ensure brevity in your answer.  0.52. What is the ratio of the ATMs(per 100,000 adults) in Suriname in 2008 to that in 2012?
Ensure brevity in your answer.  0.68. What is the ratio of the ATMs(per 100,000 adults) in Honduras in 2008 to that in 2013?
Provide a short and direct response. 0.57. What is the ratio of the ATMs(per 100,000 adults) of Hungary in 2008 to that in 2013?
Offer a very short reply. 0.95. What is the ratio of the ATMs(per 100,000 adults) of Peru in 2008 to that in 2013?
Offer a very short reply. 0.49. What is the ratio of the ATMs(per 100,000 adults) of Suriname in 2008 to that in 2013?
Your answer should be compact. 0.66. What is the ratio of the ATMs(per 100,000 adults) of Honduras in 2009 to that in 2010?
Ensure brevity in your answer.  0.96. What is the ratio of the ATMs(per 100,000 adults) in Hungary in 2009 to that in 2010?
Offer a very short reply. 0.98. What is the ratio of the ATMs(per 100,000 adults) in Peru in 2009 to that in 2010?
Offer a terse response. 0.88. What is the ratio of the ATMs(per 100,000 adults) in Suriname in 2009 to that in 2010?
Your response must be concise. 0.97. What is the ratio of the ATMs(per 100,000 adults) of Honduras in 2009 to that in 2011?
Give a very brief answer. 0.73. What is the ratio of the ATMs(per 100,000 adults) of Hungary in 2009 to that in 2011?
Offer a very short reply. 0.96. What is the ratio of the ATMs(per 100,000 adults) in Peru in 2009 to that in 2011?
Ensure brevity in your answer.  0.76. What is the ratio of the ATMs(per 100,000 adults) in Suriname in 2009 to that in 2011?
Keep it short and to the point. 0.93. What is the ratio of the ATMs(per 100,000 adults) of Honduras in 2009 to that in 2012?
Your response must be concise. 0.71. What is the ratio of the ATMs(per 100,000 adults) in Hungary in 2009 to that in 2012?
Offer a very short reply. 0.98. What is the ratio of the ATMs(per 100,000 adults) in Peru in 2009 to that in 2012?
Your answer should be compact. 0.62. What is the ratio of the ATMs(per 100,000 adults) in Suriname in 2009 to that in 2012?
Keep it short and to the point. 0.82. What is the ratio of the ATMs(per 100,000 adults) of Honduras in 2009 to that in 2013?
Offer a terse response. 0.68. What is the ratio of the ATMs(per 100,000 adults) in Peru in 2009 to that in 2013?
Offer a very short reply. 0.58. What is the ratio of the ATMs(per 100,000 adults) of Suriname in 2009 to that in 2013?
Your answer should be very brief. 0.81. What is the ratio of the ATMs(per 100,000 adults) in Honduras in 2010 to that in 2011?
Your response must be concise. 0.76. What is the ratio of the ATMs(per 100,000 adults) of Hungary in 2010 to that in 2011?
Your answer should be very brief. 0.98. What is the ratio of the ATMs(per 100,000 adults) of Peru in 2010 to that in 2011?
Ensure brevity in your answer.  0.86. What is the ratio of the ATMs(per 100,000 adults) in Suriname in 2010 to that in 2011?
Offer a very short reply. 0.96. What is the ratio of the ATMs(per 100,000 adults) in Honduras in 2010 to that in 2012?
Your response must be concise. 0.74. What is the ratio of the ATMs(per 100,000 adults) of Hungary in 2010 to that in 2012?
Offer a terse response. 1. What is the ratio of the ATMs(per 100,000 adults) in Peru in 2010 to that in 2012?
Give a very brief answer. 0.7. What is the ratio of the ATMs(per 100,000 adults) of Suriname in 2010 to that in 2012?
Make the answer very short. 0.85. What is the ratio of the ATMs(per 100,000 adults) of Honduras in 2010 to that in 2013?
Provide a short and direct response. 0.71. What is the ratio of the ATMs(per 100,000 adults) in Hungary in 2010 to that in 2013?
Keep it short and to the point. 0.99. What is the ratio of the ATMs(per 100,000 adults) of Peru in 2010 to that in 2013?
Your answer should be compact. 0.65. What is the ratio of the ATMs(per 100,000 adults) in Suriname in 2010 to that in 2013?
Your response must be concise. 0.83. What is the ratio of the ATMs(per 100,000 adults) of Honduras in 2011 to that in 2012?
Ensure brevity in your answer.  0.98. What is the ratio of the ATMs(per 100,000 adults) of Hungary in 2011 to that in 2012?
Your answer should be compact. 1.02. What is the ratio of the ATMs(per 100,000 adults) of Peru in 2011 to that in 2012?
Provide a short and direct response. 0.81. What is the ratio of the ATMs(per 100,000 adults) in Suriname in 2011 to that in 2012?
Your answer should be very brief. 0.88. What is the ratio of the ATMs(per 100,000 adults) in Honduras in 2011 to that in 2013?
Keep it short and to the point. 0.93. What is the ratio of the ATMs(per 100,000 adults) of Peru in 2011 to that in 2013?
Your response must be concise. 0.76. What is the ratio of the ATMs(per 100,000 adults) in Suriname in 2011 to that in 2013?
Make the answer very short. 0.86. What is the ratio of the ATMs(per 100,000 adults) of Honduras in 2012 to that in 2013?
Provide a succinct answer. 0.95. What is the ratio of the ATMs(per 100,000 adults) of Hungary in 2012 to that in 2013?
Provide a succinct answer. 0.99. What is the ratio of the ATMs(per 100,000 adults) in Peru in 2012 to that in 2013?
Provide a short and direct response. 0.93. What is the ratio of the ATMs(per 100,000 adults) of Suriname in 2012 to that in 2013?
Your answer should be compact. 0.98. What is the difference between the highest and the second highest ATMs(per 100,000 adults) of Honduras?
Provide a succinct answer. 1.22. What is the difference between the highest and the second highest ATMs(per 100,000 adults) in Hungary?
Provide a short and direct response. 0.41. What is the difference between the highest and the second highest ATMs(per 100,000 adults) in Peru?
Your answer should be compact. 2.69. What is the difference between the highest and the second highest ATMs(per 100,000 adults) of Suriname?
Your response must be concise. 0.9. What is the difference between the highest and the lowest ATMs(per 100,000 adults) of Honduras?
Keep it short and to the point. 13.61. What is the difference between the highest and the lowest ATMs(per 100,000 adults) of Hungary?
Give a very brief answer. 7.45. What is the difference between the highest and the lowest ATMs(per 100,000 adults) in Peru?
Provide a succinct answer. 24.68. What is the difference between the highest and the lowest ATMs(per 100,000 adults) in Suriname?
Your response must be concise. 14.39. 